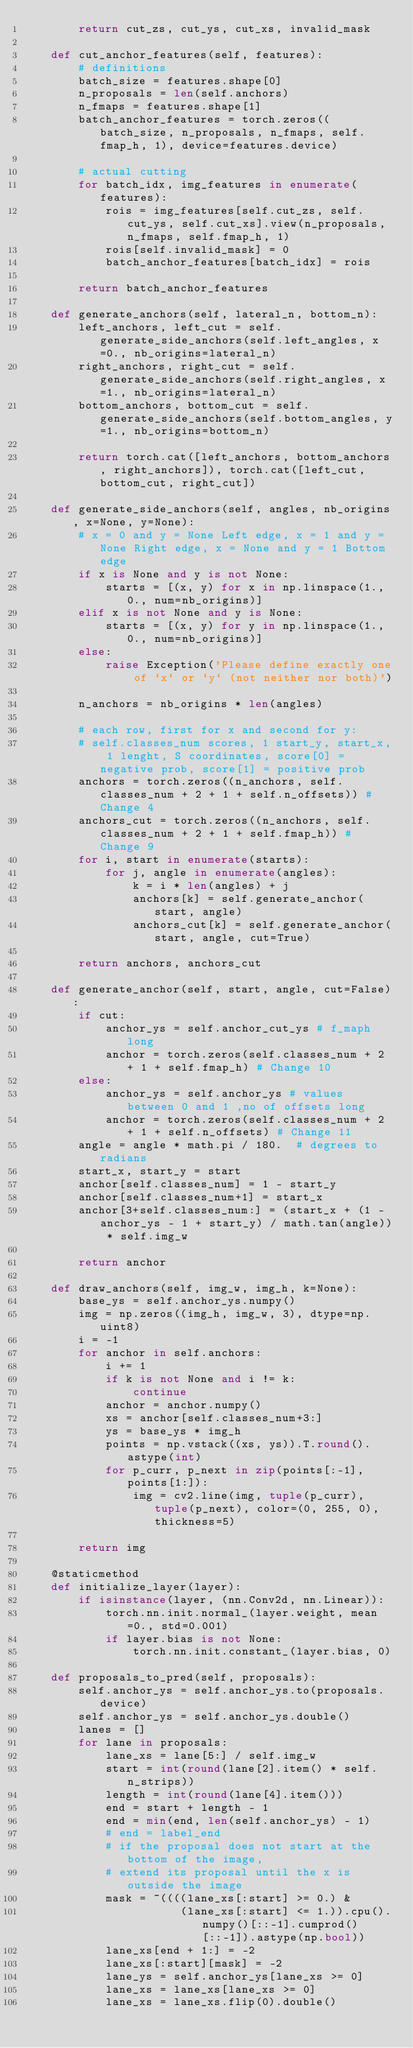Convert code to text. <code><loc_0><loc_0><loc_500><loc_500><_Python_>        return cut_zs, cut_ys, cut_xs, invalid_mask

    def cut_anchor_features(self, features):
        # definitions
        batch_size = features.shape[0]
        n_proposals = len(self.anchors)
        n_fmaps = features.shape[1]
        batch_anchor_features = torch.zeros((batch_size, n_proposals, n_fmaps, self.fmap_h, 1), device=features.device)

        # actual cutting
        for batch_idx, img_features in enumerate(features):
            rois = img_features[self.cut_zs, self.cut_ys, self.cut_xs].view(n_proposals, n_fmaps, self.fmap_h, 1)
            rois[self.invalid_mask] = 0
            batch_anchor_features[batch_idx] = rois

        return batch_anchor_features

    def generate_anchors(self, lateral_n, bottom_n):
        left_anchors, left_cut = self.generate_side_anchors(self.left_angles, x=0., nb_origins=lateral_n)
        right_anchors, right_cut = self.generate_side_anchors(self.right_angles, x=1., nb_origins=lateral_n)
        bottom_anchors, bottom_cut = self.generate_side_anchors(self.bottom_angles, y=1., nb_origins=bottom_n)

        return torch.cat([left_anchors, bottom_anchors, right_anchors]), torch.cat([left_cut, bottom_cut, right_cut])

    def generate_side_anchors(self, angles, nb_origins, x=None, y=None):
        # x = 0 and y = None Left edge, x = 1 and y = None Right edge, x = None and y = 1 Bottom edge
        if x is None and y is not None:
            starts = [(x, y) for x in np.linspace(1., 0., num=nb_origins)]
        elif x is not None and y is None:
            starts = [(x, y) for y in np.linspace(1., 0., num=nb_origins)]
        else:
            raise Exception('Please define exactly one of `x` or `y` (not neither nor both)')

        n_anchors = nb_origins * len(angles)

        # each row, first for x and second for y:
        # self.classes_num scores, 1 start_y, start_x, 1 lenght, S coordinates, score[0] = negative prob, score[1] = positive prob
        anchors = torch.zeros((n_anchors, self.classes_num + 2 + 1 + self.n_offsets)) # Change 4
        anchors_cut = torch.zeros((n_anchors, self.classes_num + 2 + 1 + self.fmap_h)) # Change 9
        for i, start in enumerate(starts):
            for j, angle in enumerate(angles):
                k = i * len(angles) + j
                anchors[k] = self.generate_anchor(start, angle)
                anchors_cut[k] = self.generate_anchor(start, angle, cut=True)

        return anchors, anchors_cut

    def generate_anchor(self, start, angle, cut=False):
        if cut:
            anchor_ys = self.anchor_cut_ys # f_maph long
            anchor = torch.zeros(self.classes_num + 2 + 1 + self.fmap_h) # Change 10
        else:
            anchor_ys = self.anchor_ys # values between 0 and 1 ,no of offsets long
            anchor = torch.zeros(self.classes_num + 2 + 1 + self.n_offsets) # Change 11
        angle = angle * math.pi / 180.  # degrees to radians
        start_x, start_y = start
        anchor[self.classes_num] = 1 - start_y
        anchor[self.classes_num+1] = start_x
        anchor[3+self.classes_num:] = (start_x + (1 - anchor_ys - 1 + start_y) / math.tan(angle)) * self.img_w

        return anchor

    def draw_anchors(self, img_w, img_h, k=None):
        base_ys = self.anchor_ys.numpy()
        img = np.zeros((img_h, img_w, 3), dtype=np.uint8)
        i = -1
        for anchor in self.anchors:
            i += 1
            if k is not None and i != k:
                continue
            anchor = anchor.numpy()
            xs = anchor[self.classes_num+3:]
            ys = base_ys * img_h
            points = np.vstack((xs, ys)).T.round().astype(int)
            for p_curr, p_next in zip(points[:-1], points[1:]):
                img = cv2.line(img, tuple(p_curr), tuple(p_next), color=(0, 255, 0), thickness=5)

        return img

    @staticmethod
    def initialize_layer(layer):
        if isinstance(layer, (nn.Conv2d, nn.Linear)):
            torch.nn.init.normal_(layer.weight, mean=0., std=0.001)
            if layer.bias is not None:
                torch.nn.init.constant_(layer.bias, 0)

    def proposals_to_pred(self, proposals):
        self.anchor_ys = self.anchor_ys.to(proposals.device)
        self.anchor_ys = self.anchor_ys.double()
        lanes = []
        for lane in proposals:
            lane_xs = lane[5:] / self.img_w
            start = int(round(lane[2].item() * self.n_strips))
            length = int(round(lane[4].item()))
            end = start + length - 1
            end = min(end, len(self.anchor_ys) - 1)
            # end = label_end
            # if the proposal does not start at the bottom of the image,
            # extend its proposal until the x is outside the image
            mask = ~((((lane_xs[:start] >= 0.) &
                       (lane_xs[:start] <= 1.)).cpu().numpy()[::-1].cumprod()[::-1]).astype(np.bool))
            lane_xs[end + 1:] = -2
            lane_xs[:start][mask] = -2
            lane_ys = self.anchor_ys[lane_xs >= 0]
            lane_xs = lane_xs[lane_xs >= 0]
            lane_xs = lane_xs.flip(0).double()</code> 